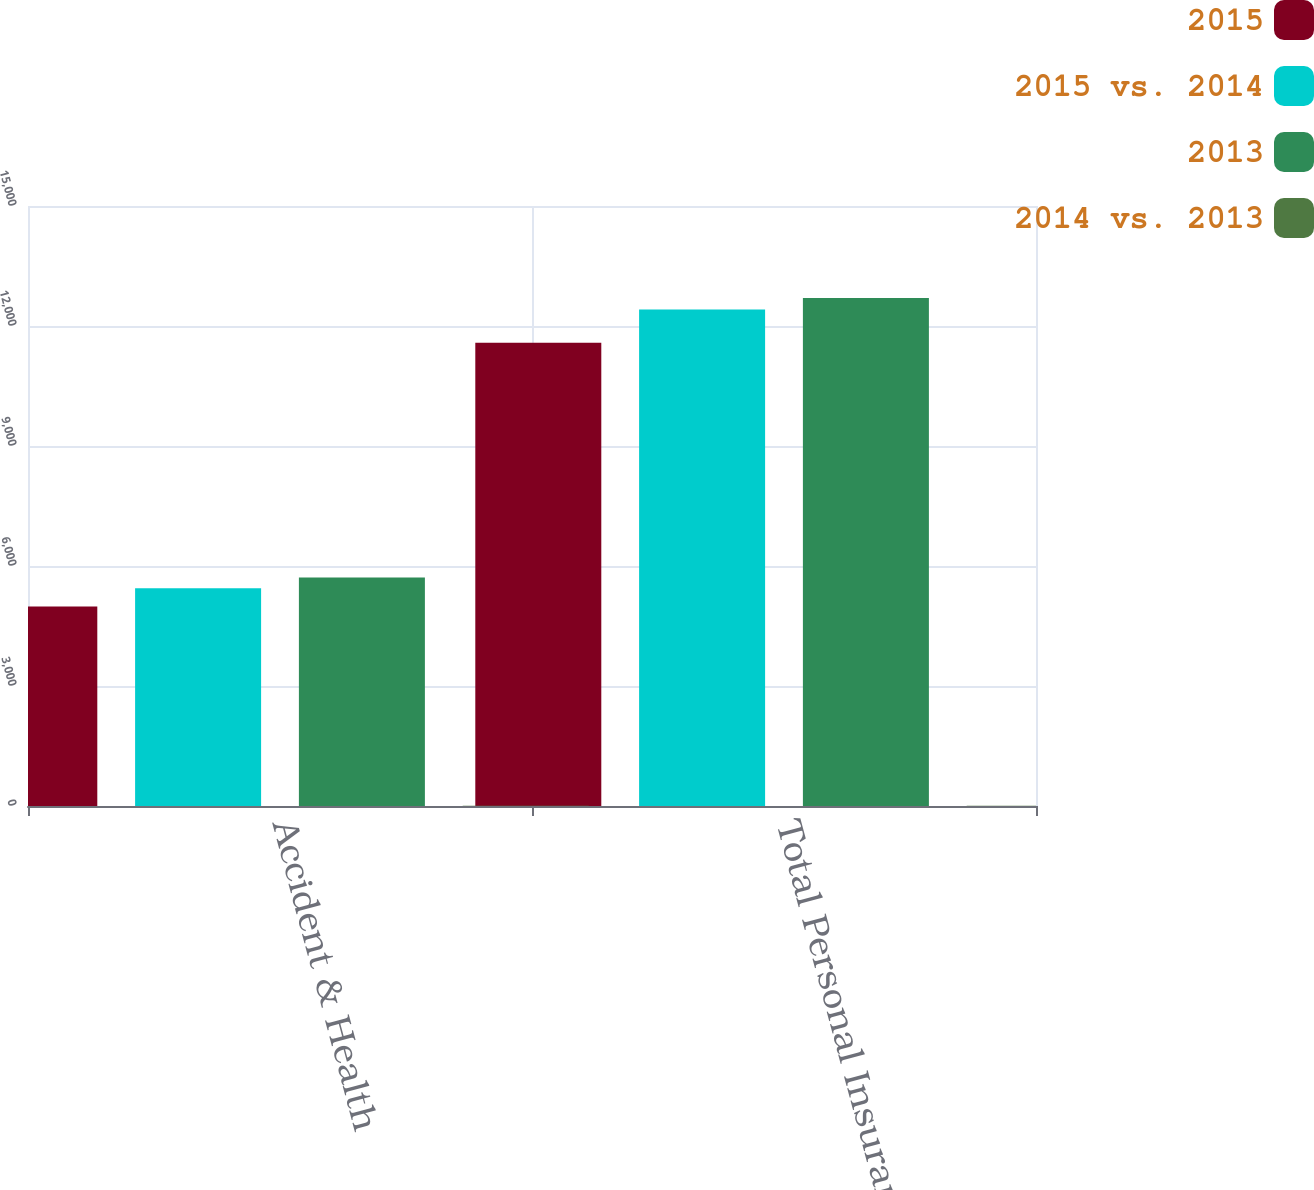Convert chart to OTSL. <chart><loc_0><loc_0><loc_500><loc_500><stacked_bar_chart><ecel><fcel>Accident & Health<fcel>Total Personal Insurance net<nl><fcel>2015<fcel>4990<fcel>11580<nl><fcel>2015 vs. 2014<fcel>5441<fcel>12412<nl><fcel>2013<fcel>5714<fcel>12700<nl><fcel>2014 vs. 2013<fcel>8<fcel>7<nl></chart> 